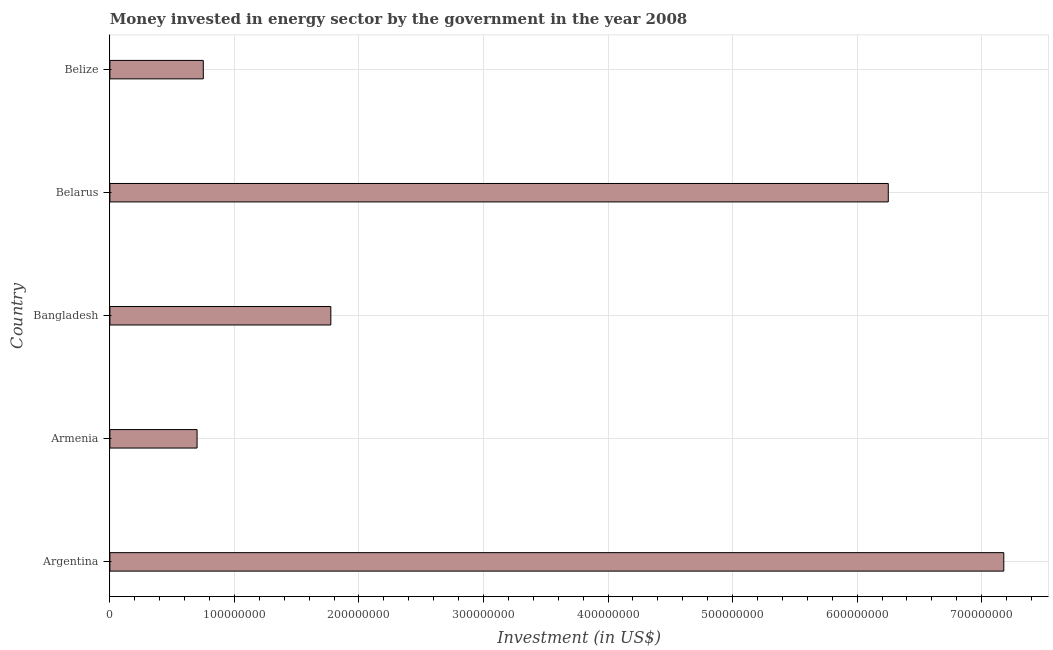Does the graph contain grids?
Keep it short and to the point. Yes. What is the title of the graph?
Provide a short and direct response. Money invested in energy sector by the government in the year 2008. What is the label or title of the X-axis?
Provide a short and direct response. Investment (in US$). What is the investment in energy in Belarus?
Make the answer very short. 6.25e+08. Across all countries, what is the maximum investment in energy?
Offer a very short reply. 7.18e+08. Across all countries, what is the minimum investment in energy?
Provide a short and direct response. 7.00e+07. In which country was the investment in energy maximum?
Make the answer very short. Argentina. In which country was the investment in energy minimum?
Keep it short and to the point. Armenia. What is the sum of the investment in energy?
Make the answer very short. 1.67e+09. What is the difference between the investment in energy in Argentina and Belarus?
Make the answer very short. 9.28e+07. What is the average investment in energy per country?
Your response must be concise. 3.33e+08. What is the median investment in energy?
Keep it short and to the point. 1.77e+08. What is the ratio of the investment in energy in Argentina to that in Belize?
Keep it short and to the point. 9.57. Is the difference between the investment in energy in Armenia and Belarus greater than the difference between any two countries?
Ensure brevity in your answer.  No. What is the difference between the highest and the second highest investment in energy?
Give a very brief answer. 9.28e+07. What is the difference between the highest and the lowest investment in energy?
Offer a terse response. 6.48e+08. How many countries are there in the graph?
Offer a very short reply. 5. What is the difference between two consecutive major ticks on the X-axis?
Your response must be concise. 1.00e+08. Are the values on the major ticks of X-axis written in scientific E-notation?
Your answer should be compact. No. What is the Investment (in US$) in Argentina?
Offer a terse response. 7.18e+08. What is the Investment (in US$) in Armenia?
Your answer should be compact. 7.00e+07. What is the Investment (in US$) of Bangladesh?
Your answer should be very brief. 1.77e+08. What is the Investment (in US$) of Belarus?
Provide a succinct answer. 6.25e+08. What is the Investment (in US$) of Belize?
Your answer should be very brief. 7.50e+07. What is the difference between the Investment (in US$) in Argentina and Armenia?
Give a very brief answer. 6.48e+08. What is the difference between the Investment (in US$) in Argentina and Bangladesh?
Give a very brief answer. 5.40e+08. What is the difference between the Investment (in US$) in Argentina and Belarus?
Ensure brevity in your answer.  9.28e+07. What is the difference between the Investment (in US$) in Argentina and Belize?
Provide a short and direct response. 6.43e+08. What is the difference between the Investment (in US$) in Armenia and Bangladesh?
Your answer should be compact. -1.07e+08. What is the difference between the Investment (in US$) in Armenia and Belarus?
Your answer should be very brief. -5.55e+08. What is the difference between the Investment (in US$) in Armenia and Belize?
Offer a very short reply. -5.00e+06. What is the difference between the Investment (in US$) in Bangladesh and Belarus?
Provide a succinct answer. -4.48e+08. What is the difference between the Investment (in US$) in Bangladesh and Belize?
Offer a terse response. 1.02e+08. What is the difference between the Investment (in US$) in Belarus and Belize?
Provide a succinct answer. 5.50e+08. What is the ratio of the Investment (in US$) in Argentina to that in Armenia?
Your answer should be very brief. 10.25. What is the ratio of the Investment (in US$) in Argentina to that in Bangladesh?
Give a very brief answer. 4.05. What is the ratio of the Investment (in US$) in Argentina to that in Belarus?
Make the answer very short. 1.15. What is the ratio of the Investment (in US$) in Argentina to that in Belize?
Your answer should be compact. 9.57. What is the ratio of the Investment (in US$) in Armenia to that in Bangladesh?
Keep it short and to the point. 0.4. What is the ratio of the Investment (in US$) in Armenia to that in Belarus?
Your answer should be compact. 0.11. What is the ratio of the Investment (in US$) in Armenia to that in Belize?
Provide a succinct answer. 0.93. What is the ratio of the Investment (in US$) in Bangladesh to that in Belarus?
Your answer should be compact. 0.28. What is the ratio of the Investment (in US$) in Bangladesh to that in Belize?
Provide a short and direct response. 2.37. What is the ratio of the Investment (in US$) in Belarus to that in Belize?
Give a very brief answer. 8.33. 